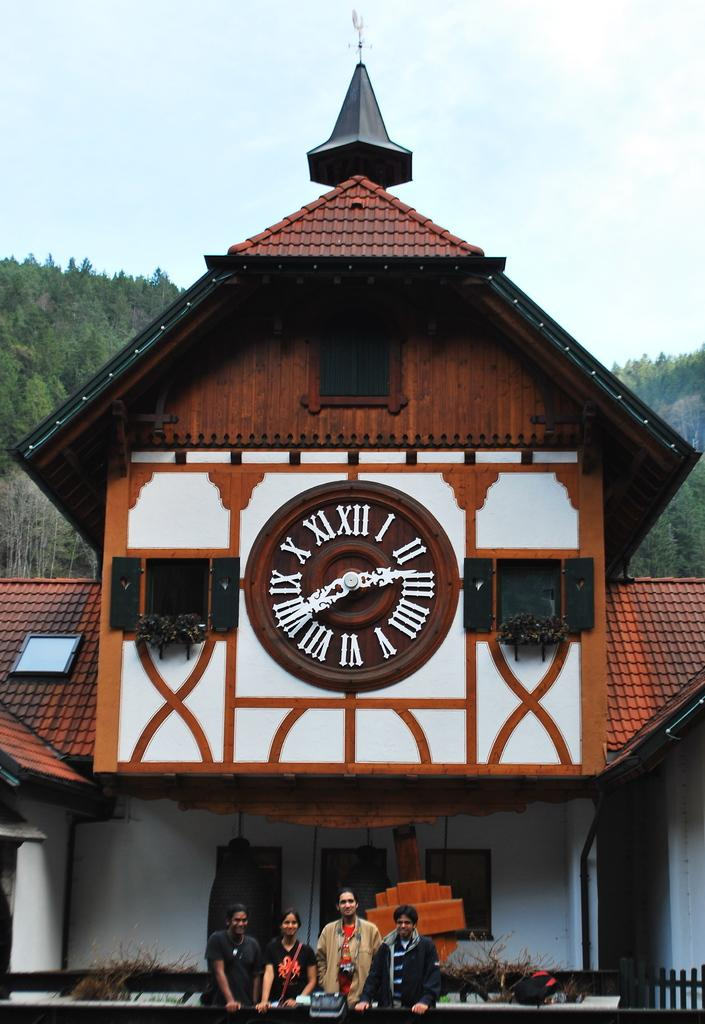Provide a one-sentence caption for the provided image. Four people posing in front of a building with a large clock showing the time of 2:40. 